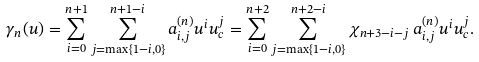<formula> <loc_0><loc_0><loc_500><loc_500>\gamma _ { n } ( u ) = \sum _ { i = 0 } ^ { n + 1 } \sum _ { j = \max \{ 1 - i , 0 \} } ^ { n + 1 - i } a _ { i , j } ^ { ( n ) } u ^ { i } u _ { c } ^ { j } = \sum _ { i = 0 } ^ { n + 2 } \sum _ { j = \max \{ 1 - i , 0 \} } ^ { n + 2 - i } \chi _ { n + 3 - i - j } \, a _ { i , j } ^ { ( n ) } u ^ { i } u _ { c } ^ { j } .</formula> 